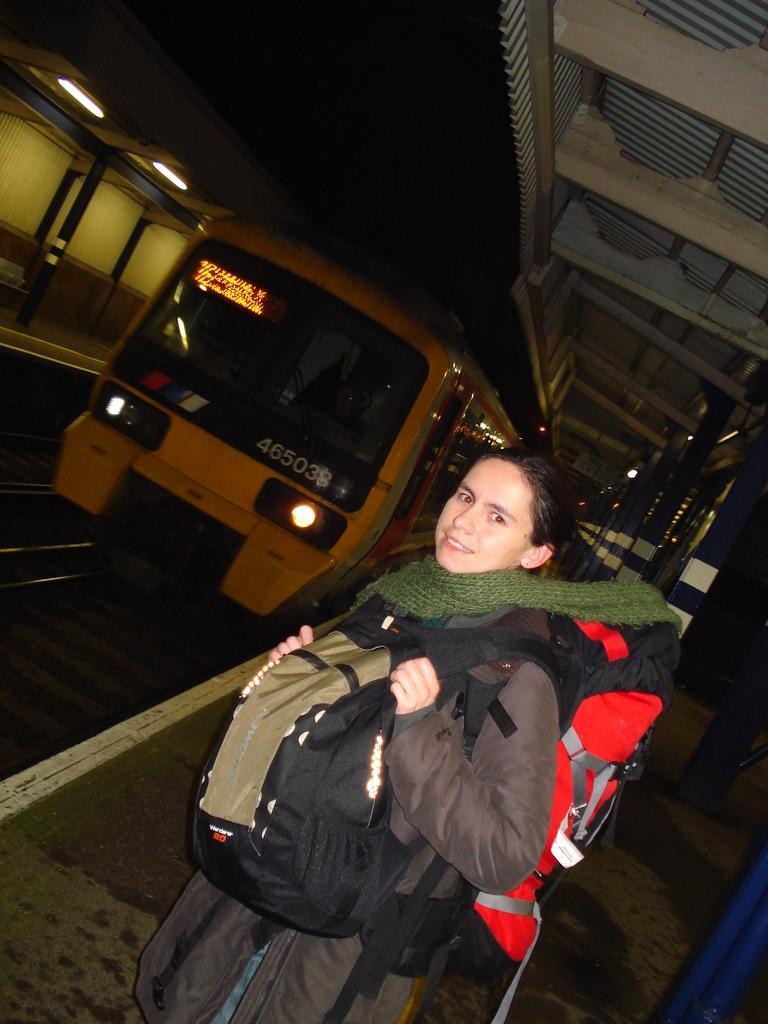Describe this image in one or two sentences. In this picture there is a woman who is wearing jacket, scarf, jeans and two bags. She is standing on the platform, beside her i can see the pillars. In the top right there is a shed. On the left there is a train on the railway track. In the top left corner i can see the tube lights on the roof of the shed which is on the other platform. At the top i can see the darkness. 